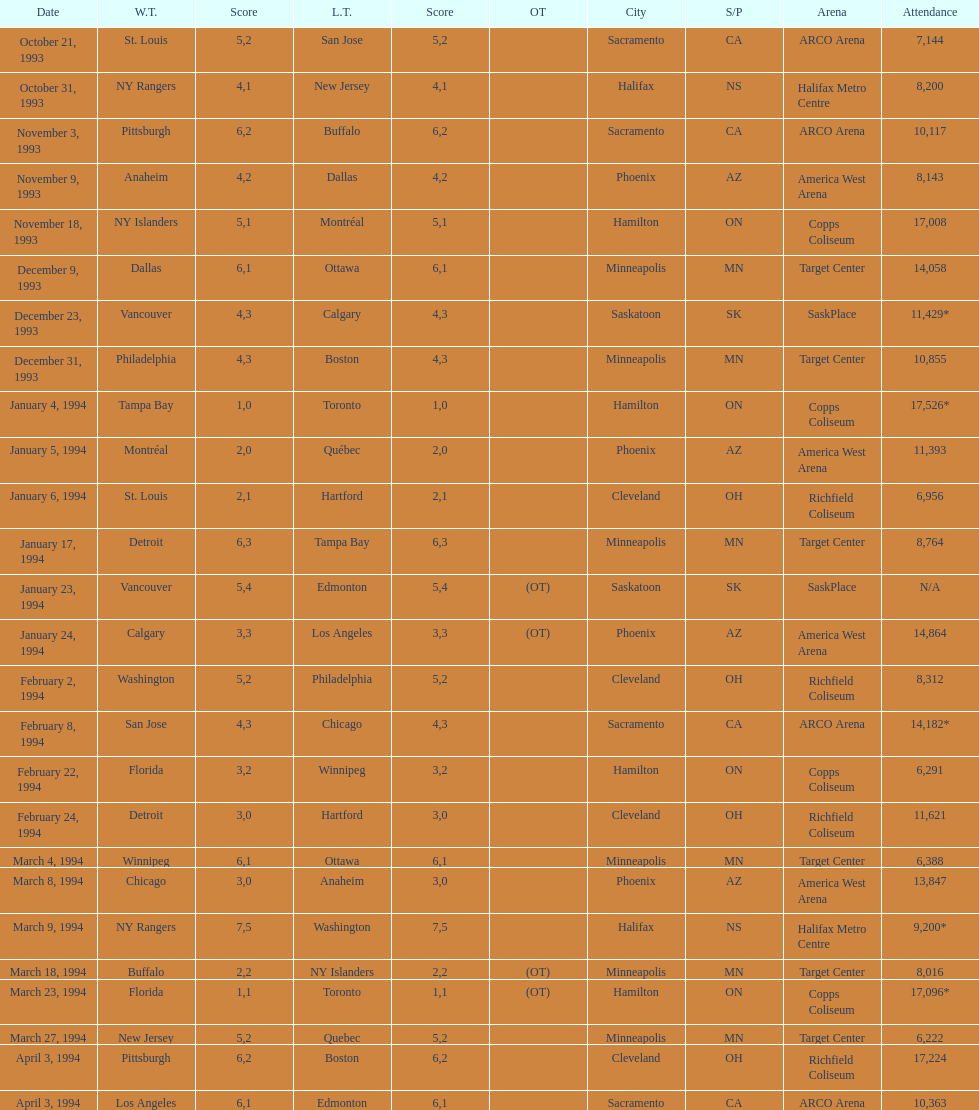Was it dallas or ottawa that won the game on december 9, 1993? Dallas. 